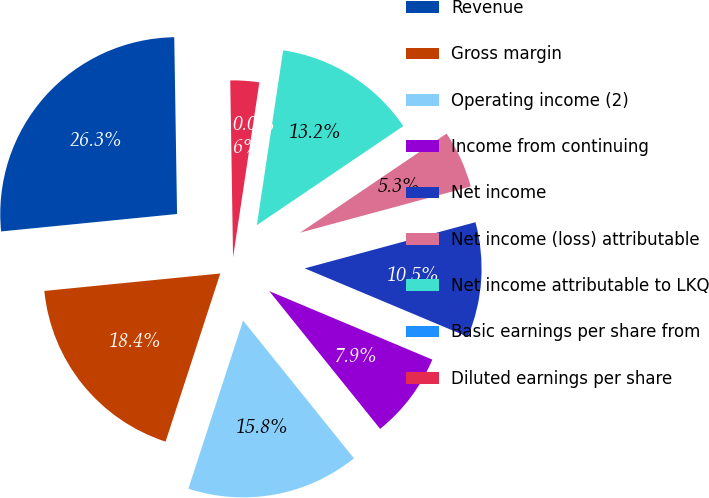Convert chart to OTSL. <chart><loc_0><loc_0><loc_500><loc_500><pie_chart><fcel>Revenue<fcel>Gross margin<fcel>Operating income (2)<fcel>Income from continuing<fcel>Net income<fcel>Net income (loss) attributable<fcel>Net income attributable to LKQ<fcel>Basic earnings per share from<fcel>Diluted earnings per share<nl><fcel>26.32%<fcel>18.42%<fcel>15.79%<fcel>7.89%<fcel>10.53%<fcel>5.26%<fcel>13.16%<fcel>0.0%<fcel>2.63%<nl></chart> 